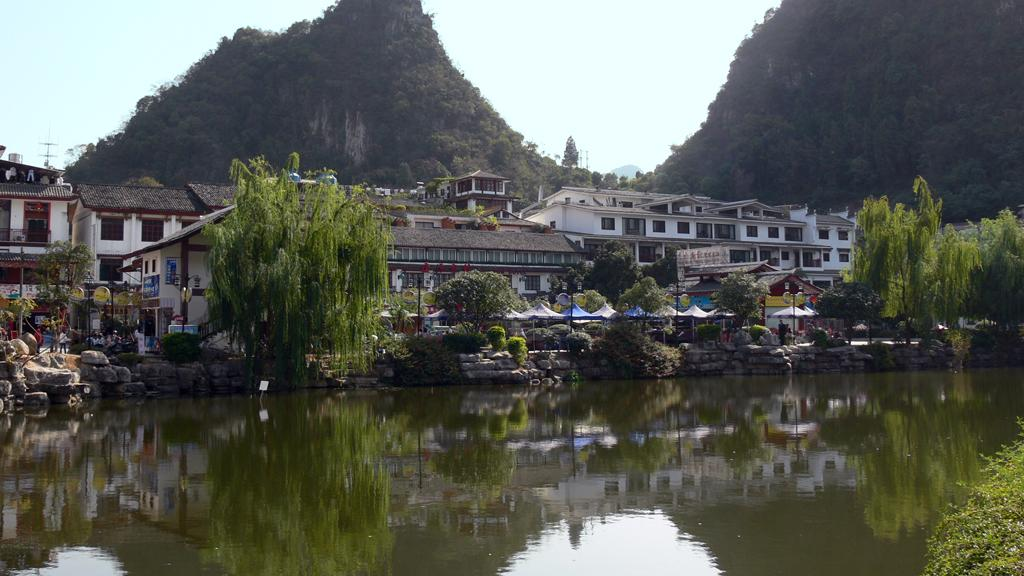What is the primary element visible in the image? There is water in the image. What other natural elements can be seen in the image? There are trees, rocks, mountains, and plants in the image. Are there any man-made structures visible in the image? Yes, there are buildings in the image. What is visible in the background of the image? The sky is visible in the background of the image. Can you see a pig swinging on a suit in the image? No, there is no pig or suit present in the image. 